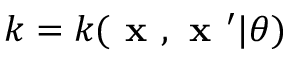Convert formula to latex. <formula><loc_0><loc_0><loc_500><loc_500>k = k ( x , x ^ { \prime } | \theta )</formula> 